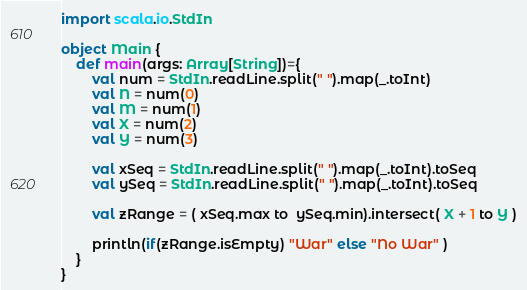Convert code to text. <code><loc_0><loc_0><loc_500><loc_500><_Scala_>import scala.io.StdIn

object Main {
	def main(args: Array[String])={
		val num = StdIn.readLine.split(" ").map(_.toInt)
		val N = num(0)
		val M = num(1)
		val X = num(2)
		val Y = num(3)

		val xSeq = StdIn.readLine.split(" ").map(_.toInt).toSeq
		val ySeq = StdIn.readLine.split(" ").map(_.toInt).toSeq

		val zRange = ( xSeq.max to  ySeq.min).intersect( X + 1 to Y )

		println(if(zRange.isEmpty) "War" else "No War" )
	}
}</code> 